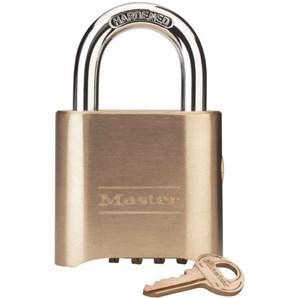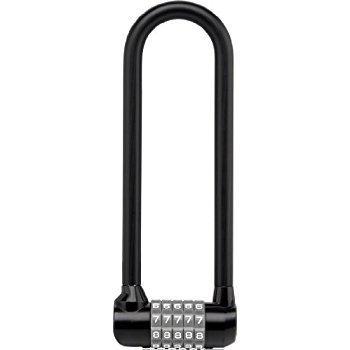The first image is the image on the left, the second image is the image on the right. For the images shown, is this caption "One lock is round with a black number dial, which the other is roughly square with four scrolling number belts." true? Answer yes or no. No. The first image is the image on the left, the second image is the image on the right. Given the left and right images, does the statement "One of the locks is round in shape." hold true? Answer yes or no. No. 